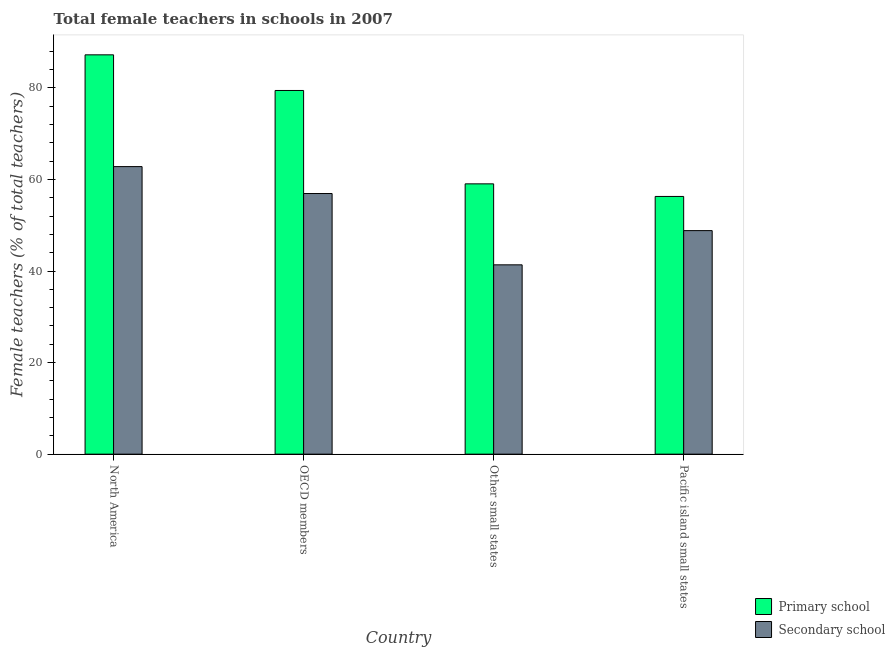How many different coloured bars are there?
Your response must be concise. 2. How many groups of bars are there?
Your response must be concise. 4. Are the number of bars per tick equal to the number of legend labels?
Give a very brief answer. Yes. Are the number of bars on each tick of the X-axis equal?
Provide a succinct answer. Yes. How many bars are there on the 1st tick from the left?
Make the answer very short. 2. What is the label of the 3rd group of bars from the left?
Offer a terse response. Other small states. What is the percentage of female teachers in primary schools in Other small states?
Your response must be concise. 59.04. Across all countries, what is the maximum percentage of female teachers in primary schools?
Your answer should be very brief. 87.22. Across all countries, what is the minimum percentage of female teachers in primary schools?
Provide a short and direct response. 56.29. In which country was the percentage of female teachers in secondary schools minimum?
Make the answer very short. Other small states. What is the total percentage of female teachers in secondary schools in the graph?
Your response must be concise. 209.93. What is the difference between the percentage of female teachers in primary schools in North America and that in Pacific island small states?
Your answer should be very brief. 30.93. What is the difference between the percentage of female teachers in secondary schools in OECD members and the percentage of female teachers in primary schools in Other small states?
Keep it short and to the point. -2.11. What is the average percentage of female teachers in primary schools per country?
Provide a short and direct response. 70.5. What is the difference between the percentage of female teachers in secondary schools and percentage of female teachers in primary schools in Pacific island small states?
Offer a terse response. -7.46. In how many countries, is the percentage of female teachers in secondary schools greater than 20 %?
Your answer should be very brief. 4. What is the ratio of the percentage of female teachers in primary schools in North America to that in OECD members?
Give a very brief answer. 1.1. Is the difference between the percentage of female teachers in secondary schools in North America and Other small states greater than the difference between the percentage of female teachers in primary schools in North America and Other small states?
Give a very brief answer. No. What is the difference between the highest and the second highest percentage of female teachers in secondary schools?
Your answer should be compact. 5.88. What is the difference between the highest and the lowest percentage of female teachers in primary schools?
Offer a terse response. 30.93. Is the sum of the percentage of female teachers in primary schools in OECD members and Pacific island small states greater than the maximum percentage of female teachers in secondary schools across all countries?
Keep it short and to the point. Yes. What does the 2nd bar from the left in OECD members represents?
Give a very brief answer. Secondary school. What does the 2nd bar from the right in Pacific island small states represents?
Offer a very short reply. Primary school. How many bars are there?
Ensure brevity in your answer.  8. Are all the bars in the graph horizontal?
Make the answer very short. No. Are the values on the major ticks of Y-axis written in scientific E-notation?
Keep it short and to the point. No. Does the graph contain any zero values?
Your answer should be very brief. No. Does the graph contain grids?
Keep it short and to the point. No. Where does the legend appear in the graph?
Offer a very short reply. Bottom right. What is the title of the graph?
Give a very brief answer. Total female teachers in schools in 2007. What is the label or title of the Y-axis?
Ensure brevity in your answer.  Female teachers (% of total teachers). What is the Female teachers (% of total teachers) in Primary school in North America?
Keep it short and to the point. 87.22. What is the Female teachers (% of total teachers) of Secondary school in North America?
Make the answer very short. 62.81. What is the Female teachers (% of total teachers) of Primary school in OECD members?
Your response must be concise. 79.44. What is the Female teachers (% of total teachers) of Secondary school in OECD members?
Your answer should be very brief. 56.93. What is the Female teachers (% of total teachers) in Primary school in Other small states?
Your answer should be compact. 59.04. What is the Female teachers (% of total teachers) in Secondary school in Other small states?
Provide a succinct answer. 41.36. What is the Female teachers (% of total teachers) in Primary school in Pacific island small states?
Your answer should be compact. 56.29. What is the Female teachers (% of total teachers) in Secondary school in Pacific island small states?
Provide a succinct answer. 48.83. Across all countries, what is the maximum Female teachers (% of total teachers) of Primary school?
Make the answer very short. 87.22. Across all countries, what is the maximum Female teachers (% of total teachers) of Secondary school?
Keep it short and to the point. 62.81. Across all countries, what is the minimum Female teachers (% of total teachers) of Primary school?
Your answer should be compact. 56.29. Across all countries, what is the minimum Female teachers (% of total teachers) in Secondary school?
Keep it short and to the point. 41.36. What is the total Female teachers (% of total teachers) of Primary school in the graph?
Ensure brevity in your answer.  281.99. What is the total Female teachers (% of total teachers) of Secondary school in the graph?
Make the answer very short. 209.93. What is the difference between the Female teachers (% of total teachers) of Primary school in North America and that in OECD members?
Ensure brevity in your answer.  7.78. What is the difference between the Female teachers (% of total teachers) of Secondary school in North America and that in OECD members?
Provide a short and direct response. 5.88. What is the difference between the Female teachers (% of total teachers) in Primary school in North America and that in Other small states?
Keep it short and to the point. 28.18. What is the difference between the Female teachers (% of total teachers) in Secondary school in North America and that in Other small states?
Your answer should be very brief. 21.46. What is the difference between the Female teachers (% of total teachers) in Primary school in North America and that in Pacific island small states?
Your answer should be very brief. 30.93. What is the difference between the Female teachers (% of total teachers) in Secondary school in North America and that in Pacific island small states?
Provide a succinct answer. 13.98. What is the difference between the Female teachers (% of total teachers) in Primary school in OECD members and that in Other small states?
Offer a terse response. 20.39. What is the difference between the Female teachers (% of total teachers) of Secondary school in OECD members and that in Other small states?
Make the answer very short. 15.58. What is the difference between the Female teachers (% of total teachers) in Primary school in OECD members and that in Pacific island small states?
Keep it short and to the point. 23.14. What is the difference between the Female teachers (% of total teachers) of Secondary school in OECD members and that in Pacific island small states?
Your answer should be very brief. 8.1. What is the difference between the Female teachers (% of total teachers) in Primary school in Other small states and that in Pacific island small states?
Ensure brevity in your answer.  2.75. What is the difference between the Female teachers (% of total teachers) in Secondary school in Other small states and that in Pacific island small states?
Your answer should be compact. -7.47. What is the difference between the Female teachers (% of total teachers) of Primary school in North America and the Female teachers (% of total teachers) of Secondary school in OECD members?
Keep it short and to the point. 30.29. What is the difference between the Female teachers (% of total teachers) in Primary school in North America and the Female teachers (% of total teachers) in Secondary school in Other small states?
Your answer should be compact. 45.87. What is the difference between the Female teachers (% of total teachers) in Primary school in North America and the Female teachers (% of total teachers) in Secondary school in Pacific island small states?
Keep it short and to the point. 38.39. What is the difference between the Female teachers (% of total teachers) of Primary school in OECD members and the Female teachers (% of total teachers) of Secondary school in Other small states?
Offer a terse response. 38.08. What is the difference between the Female teachers (% of total teachers) in Primary school in OECD members and the Female teachers (% of total teachers) in Secondary school in Pacific island small states?
Provide a succinct answer. 30.61. What is the difference between the Female teachers (% of total teachers) of Primary school in Other small states and the Female teachers (% of total teachers) of Secondary school in Pacific island small states?
Offer a very short reply. 10.21. What is the average Female teachers (% of total teachers) of Primary school per country?
Keep it short and to the point. 70.5. What is the average Female teachers (% of total teachers) of Secondary school per country?
Your response must be concise. 52.48. What is the difference between the Female teachers (% of total teachers) in Primary school and Female teachers (% of total teachers) in Secondary school in North America?
Make the answer very short. 24.41. What is the difference between the Female teachers (% of total teachers) of Primary school and Female teachers (% of total teachers) of Secondary school in OECD members?
Give a very brief answer. 22.51. What is the difference between the Female teachers (% of total teachers) in Primary school and Female teachers (% of total teachers) in Secondary school in Other small states?
Give a very brief answer. 17.69. What is the difference between the Female teachers (% of total teachers) of Primary school and Female teachers (% of total teachers) of Secondary school in Pacific island small states?
Offer a terse response. 7.46. What is the ratio of the Female teachers (% of total teachers) in Primary school in North America to that in OECD members?
Ensure brevity in your answer.  1.1. What is the ratio of the Female teachers (% of total teachers) of Secondary school in North America to that in OECD members?
Provide a succinct answer. 1.1. What is the ratio of the Female teachers (% of total teachers) of Primary school in North America to that in Other small states?
Your response must be concise. 1.48. What is the ratio of the Female teachers (% of total teachers) of Secondary school in North America to that in Other small states?
Provide a succinct answer. 1.52. What is the ratio of the Female teachers (% of total teachers) of Primary school in North America to that in Pacific island small states?
Give a very brief answer. 1.55. What is the ratio of the Female teachers (% of total teachers) of Secondary school in North America to that in Pacific island small states?
Offer a very short reply. 1.29. What is the ratio of the Female teachers (% of total teachers) in Primary school in OECD members to that in Other small states?
Offer a terse response. 1.35. What is the ratio of the Female teachers (% of total teachers) in Secondary school in OECD members to that in Other small states?
Provide a short and direct response. 1.38. What is the ratio of the Female teachers (% of total teachers) of Primary school in OECD members to that in Pacific island small states?
Keep it short and to the point. 1.41. What is the ratio of the Female teachers (% of total teachers) of Secondary school in OECD members to that in Pacific island small states?
Offer a very short reply. 1.17. What is the ratio of the Female teachers (% of total teachers) in Primary school in Other small states to that in Pacific island small states?
Offer a very short reply. 1.05. What is the ratio of the Female teachers (% of total teachers) in Secondary school in Other small states to that in Pacific island small states?
Your answer should be very brief. 0.85. What is the difference between the highest and the second highest Female teachers (% of total teachers) in Primary school?
Provide a short and direct response. 7.78. What is the difference between the highest and the second highest Female teachers (% of total teachers) in Secondary school?
Offer a very short reply. 5.88. What is the difference between the highest and the lowest Female teachers (% of total teachers) of Primary school?
Ensure brevity in your answer.  30.93. What is the difference between the highest and the lowest Female teachers (% of total teachers) of Secondary school?
Provide a short and direct response. 21.46. 